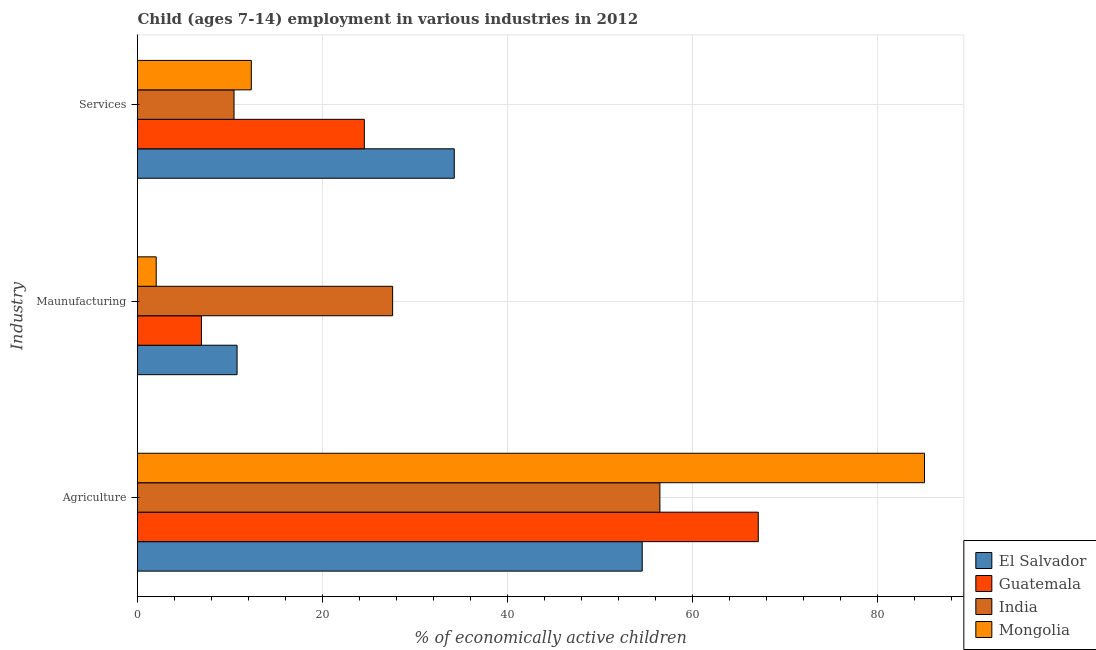How many different coloured bars are there?
Keep it short and to the point. 4. How many groups of bars are there?
Make the answer very short. 3. How many bars are there on the 1st tick from the bottom?
Make the answer very short. 4. What is the label of the 3rd group of bars from the top?
Your answer should be compact. Agriculture. What is the percentage of economically active children in manufacturing in Mongolia?
Give a very brief answer. 2.02. Across all countries, what is the maximum percentage of economically active children in agriculture?
Provide a short and direct response. 85.04. Across all countries, what is the minimum percentage of economically active children in agriculture?
Your answer should be compact. 54.54. In which country was the percentage of economically active children in manufacturing maximum?
Ensure brevity in your answer.  India. In which country was the percentage of economically active children in manufacturing minimum?
Make the answer very short. Mongolia. What is the total percentage of economically active children in manufacturing in the graph?
Offer a terse response. 47.26. What is the difference between the percentage of economically active children in agriculture in El Salvador and that in India?
Make the answer very short. -1.91. What is the difference between the percentage of economically active children in manufacturing in Mongolia and the percentage of economically active children in agriculture in India?
Your answer should be compact. -54.43. What is the average percentage of economically active children in services per country?
Provide a short and direct response. 20.37. What is the difference between the percentage of economically active children in agriculture and percentage of economically active children in services in Guatemala?
Provide a short and direct response. 42.57. In how many countries, is the percentage of economically active children in services greater than 84 %?
Provide a short and direct response. 0. What is the ratio of the percentage of economically active children in manufacturing in Guatemala to that in India?
Offer a very short reply. 0.25. Is the percentage of economically active children in agriculture in India less than that in Guatemala?
Give a very brief answer. Yes. Is the difference between the percentage of economically active children in agriculture in India and Mongolia greater than the difference between the percentage of economically active children in services in India and Mongolia?
Make the answer very short. No. What is the difference between the highest and the second highest percentage of economically active children in agriculture?
Make the answer very short. 17.96. What is the difference between the highest and the lowest percentage of economically active children in manufacturing?
Offer a very short reply. 25.55. What does the 1st bar from the top in Agriculture represents?
Offer a terse response. Mongolia. What does the 2nd bar from the bottom in Agriculture represents?
Provide a short and direct response. Guatemala. Is it the case that in every country, the sum of the percentage of economically active children in agriculture and percentage of economically active children in manufacturing is greater than the percentage of economically active children in services?
Offer a very short reply. Yes. How many bars are there?
Give a very brief answer. 12. Are all the bars in the graph horizontal?
Your answer should be very brief. Yes. How many countries are there in the graph?
Give a very brief answer. 4. Does the graph contain any zero values?
Offer a terse response. No. How many legend labels are there?
Provide a short and direct response. 4. How are the legend labels stacked?
Ensure brevity in your answer.  Vertical. What is the title of the graph?
Ensure brevity in your answer.  Child (ages 7-14) employment in various industries in 2012. Does "Norway" appear as one of the legend labels in the graph?
Offer a very short reply. No. What is the label or title of the X-axis?
Ensure brevity in your answer.  % of economically active children. What is the label or title of the Y-axis?
Your answer should be very brief. Industry. What is the % of economically active children in El Salvador in Agriculture?
Ensure brevity in your answer.  54.54. What is the % of economically active children in Guatemala in Agriculture?
Make the answer very short. 67.08. What is the % of economically active children in India in Agriculture?
Offer a very short reply. 56.45. What is the % of economically active children of Mongolia in Agriculture?
Provide a short and direct response. 85.04. What is the % of economically active children of El Salvador in Maunufacturing?
Offer a terse response. 10.76. What is the % of economically active children in Guatemala in Maunufacturing?
Keep it short and to the point. 6.91. What is the % of economically active children in India in Maunufacturing?
Offer a very short reply. 27.57. What is the % of economically active children of Mongolia in Maunufacturing?
Provide a succinct answer. 2.02. What is the % of economically active children of El Salvador in Services?
Ensure brevity in your answer.  34.23. What is the % of economically active children in Guatemala in Services?
Your response must be concise. 24.51. What is the % of economically active children in India in Services?
Your response must be concise. 10.43. What is the % of economically active children of Mongolia in Services?
Your answer should be very brief. 12.3. Across all Industry, what is the maximum % of economically active children of El Salvador?
Your answer should be very brief. 54.54. Across all Industry, what is the maximum % of economically active children of Guatemala?
Provide a succinct answer. 67.08. Across all Industry, what is the maximum % of economically active children in India?
Offer a very short reply. 56.45. Across all Industry, what is the maximum % of economically active children in Mongolia?
Ensure brevity in your answer.  85.04. Across all Industry, what is the minimum % of economically active children in El Salvador?
Offer a terse response. 10.76. Across all Industry, what is the minimum % of economically active children of Guatemala?
Give a very brief answer. 6.91. Across all Industry, what is the minimum % of economically active children in India?
Offer a terse response. 10.43. Across all Industry, what is the minimum % of economically active children of Mongolia?
Keep it short and to the point. 2.02. What is the total % of economically active children of El Salvador in the graph?
Ensure brevity in your answer.  99.53. What is the total % of economically active children in Guatemala in the graph?
Offer a very short reply. 98.5. What is the total % of economically active children of India in the graph?
Provide a short and direct response. 94.45. What is the total % of economically active children of Mongolia in the graph?
Keep it short and to the point. 99.36. What is the difference between the % of economically active children in El Salvador in Agriculture and that in Maunufacturing?
Your answer should be compact. 43.78. What is the difference between the % of economically active children of Guatemala in Agriculture and that in Maunufacturing?
Provide a succinct answer. 60.17. What is the difference between the % of economically active children in India in Agriculture and that in Maunufacturing?
Your response must be concise. 28.88. What is the difference between the % of economically active children of Mongolia in Agriculture and that in Maunufacturing?
Your response must be concise. 83.02. What is the difference between the % of economically active children in El Salvador in Agriculture and that in Services?
Provide a succinct answer. 20.31. What is the difference between the % of economically active children of Guatemala in Agriculture and that in Services?
Provide a succinct answer. 42.57. What is the difference between the % of economically active children in India in Agriculture and that in Services?
Ensure brevity in your answer.  46.02. What is the difference between the % of economically active children of Mongolia in Agriculture and that in Services?
Provide a short and direct response. 72.74. What is the difference between the % of economically active children of El Salvador in Maunufacturing and that in Services?
Offer a very short reply. -23.47. What is the difference between the % of economically active children in Guatemala in Maunufacturing and that in Services?
Offer a terse response. -17.6. What is the difference between the % of economically active children in India in Maunufacturing and that in Services?
Give a very brief answer. 17.14. What is the difference between the % of economically active children of Mongolia in Maunufacturing and that in Services?
Make the answer very short. -10.28. What is the difference between the % of economically active children of El Salvador in Agriculture and the % of economically active children of Guatemala in Maunufacturing?
Your answer should be very brief. 47.63. What is the difference between the % of economically active children of El Salvador in Agriculture and the % of economically active children of India in Maunufacturing?
Ensure brevity in your answer.  26.97. What is the difference between the % of economically active children of El Salvador in Agriculture and the % of economically active children of Mongolia in Maunufacturing?
Your answer should be very brief. 52.52. What is the difference between the % of economically active children of Guatemala in Agriculture and the % of economically active children of India in Maunufacturing?
Your response must be concise. 39.51. What is the difference between the % of economically active children of Guatemala in Agriculture and the % of economically active children of Mongolia in Maunufacturing?
Ensure brevity in your answer.  65.06. What is the difference between the % of economically active children in India in Agriculture and the % of economically active children in Mongolia in Maunufacturing?
Offer a terse response. 54.43. What is the difference between the % of economically active children of El Salvador in Agriculture and the % of economically active children of Guatemala in Services?
Ensure brevity in your answer.  30.03. What is the difference between the % of economically active children of El Salvador in Agriculture and the % of economically active children of India in Services?
Your answer should be very brief. 44.11. What is the difference between the % of economically active children in El Salvador in Agriculture and the % of economically active children in Mongolia in Services?
Offer a very short reply. 42.24. What is the difference between the % of economically active children of Guatemala in Agriculture and the % of economically active children of India in Services?
Give a very brief answer. 56.65. What is the difference between the % of economically active children of Guatemala in Agriculture and the % of economically active children of Mongolia in Services?
Keep it short and to the point. 54.78. What is the difference between the % of economically active children of India in Agriculture and the % of economically active children of Mongolia in Services?
Offer a very short reply. 44.15. What is the difference between the % of economically active children of El Salvador in Maunufacturing and the % of economically active children of Guatemala in Services?
Your answer should be compact. -13.75. What is the difference between the % of economically active children of El Salvador in Maunufacturing and the % of economically active children of India in Services?
Your answer should be compact. 0.33. What is the difference between the % of economically active children in El Salvador in Maunufacturing and the % of economically active children in Mongolia in Services?
Your response must be concise. -1.54. What is the difference between the % of economically active children in Guatemala in Maunufacturing and the % of economically active children in India in Services?
Ensure brevity in your answer.  -3.52. What is the difference between the % of economically active children in Guatemala in Maunufacturing and the % of economically active children in Mongolia in Services?
Your response must be concise. -5.39. What is the difference between the % of economically active children of India in Maunufacturing and the % of economically active children of Mongolia in Services?
Your answer should be compact. 15.27. What is the average % of economically active children in El Salvador per Industry?
Offer a very short reply. 33.18. What is the average % of economically active children in Guatemala per Industry?
Offer a very short reply. 32.83. What is the average % of economically active children in India per Industry?
Offer a terse response. 31.48. What is the average % of economically active children of Mongolia per Industry?
Offer a very short reply. 33.12. What is the difference between the % of economically active children of El Salvador and % of economically active children of Guatemala in Agriculture?
Offer a very short reply. -12.54. What is the difference between the % of economically active children of El Salvador and % of economically active children of India in Agriculture?
Your answer should be very brief. -1.91. What is the difference between the % of economically active children in El Salvador and % of economically active children in Mongolia in Agriculture?
Your response must be concise. -30.5. What is the difference between the % of economically active children in Guatemala and % of economically active children in India in Agriculture?
Your answer should be compact. 10.63. What is the difference between the % of economically active children in Guatemala and % of economically active children in Mongolia in Agriculture?
Keep it short and to the point. -17.96. What is the difference between the % of economically active children of India and % of economically active children of Mongolia in Agriculture?
Offer a terse response. -28.59. What is the difference between the % of economically active children of El Salvador and % of economically active children of Guatemala in Maunufacturing?
Ensure brevity in your answer.  3.85. What is the difference between the % of economically active children in El Salvador and % of economically active children in India in Maunufacturing?
Ensure brevity in your answer.  -16.81. What is the difference between the % of economically active children of El Salvador and % of economically active children of Mongolia in Maunufacturing?
Keep it short and to the point. 8.74. What is the difference between the % of economically active children of Guatemala and % of economically active children of India in Maunufacturing?
Keep it short and to the point. -20.66. What is the difference between the % of economically active children of Guatemala and % of economically active children of Mongolia in Maunufacturing?
Offer a terse response. 4.89. What is the difference between the % of economically active children of India and % of economically active children of Mongolia in Maunufacturing?
Make the answer very short. 25.55. What is the difference between the % of economically active children of El Salvador and % of economically active children of Guatemala in Services?
Offer a very short reply. 9.72. What is the difference between the % of economically active children in El Salvador and % of economically active children in India in Services?
Offer a terse response. 23.8. What is the difference between the % of economically active children in El Salvador and % of economically active children in Mongolia in Services?
Make the answer very short. 21.93. What is the difference between the % of economically active children of Guatemala and % of economically active children of India in Services?
Your response must be concise. 14.08. What is the difference between the % of economically active children of Guatemala and % of economically active children of Mongolia in Services?
Keep it short and to the point. 12.21. What is the difference between the % of economically active children in India and % of economically active children in Mongolia in Services?
Your answer should be very brief. -1.87. What is the ratio of the % of economically active children of El Salvador in Agriculture to that in Maunufacturing?
Provide a succinct answer. 5.07. What is the ratio of the % of economically active children in Guatemala in Agriculture to that in Maunufacturing?
Your answer should be very brief. 9.71. What is the ratio of the % of economically active children in India in Agriculture to that in Maunufacturing?
Your answer should be compact. 2.05. What is the ratio of the % of economically active children of Mongolia in Agriculture to that in Maunufacturing?
Keep it short and to the point. 42.1. What is the ratio of the % of economically active children of El Salvador in Agriculture to that in Services?
Your answer should be very brief. 1.59. What is the ratio of the % of economically active children in Guatemala in Agriculture to that in Services?
Your answer should be very brief. 2.74. What is the ratio of the % of economically active children in India in Agriculture to that in Services?
Keep it short and to the point. 5.41. What is the ratio of the % of economically active children in Mongolia in Agriculture to that in Services?
Your response must be concise. 6.91. What is the ratio of the % of economically active children of El Salvador in Maunufacturing to that in Services?
Provide a short and direct response. 0.31. What is the ratio of the % of economically active children in Guatemala in Maunufacturing to that in Services?
Offer a terse response. 0.28. What is the ratio of the % of economically active children of India in Maunufacturing to that in Services?
Make the answer very short. 2.64. What is the ratio of the % of economically active children in Mongolia in Maunufacturing to that in Services?
Ensure brevity in your answer.  0.16. What is the difference between the highest and the second highest % of economically active children of El Salvador?
Offer a very short reply. 20.31. What is the difference between the highest and the second highest % of economically active children of Guatemala?
Make the answer very short. 42.57. What is the difference between the highest and the second highest % of economically active children in India?
Give a very brief answer. 28.88. What is the difference between the highest and the second highest % of economically active children of Mongolia?
Keep it short and to the point. 72.74. What is the difference between the highest and the lowest % of economically active children of El Salvador?
Keep it short and to the point. 43.78. What is the difference between the highest and the lowest % of economically active children in Guatemala?
Your answer should be compact. 60.17. What is the difference between the highest and the lowest % of economically active children of India?
Provide a succinct answer. 46.02. What is the difference between the highest and the lowest % of economically active children of Mongolia?
Offer a very short reply. 83.02. 